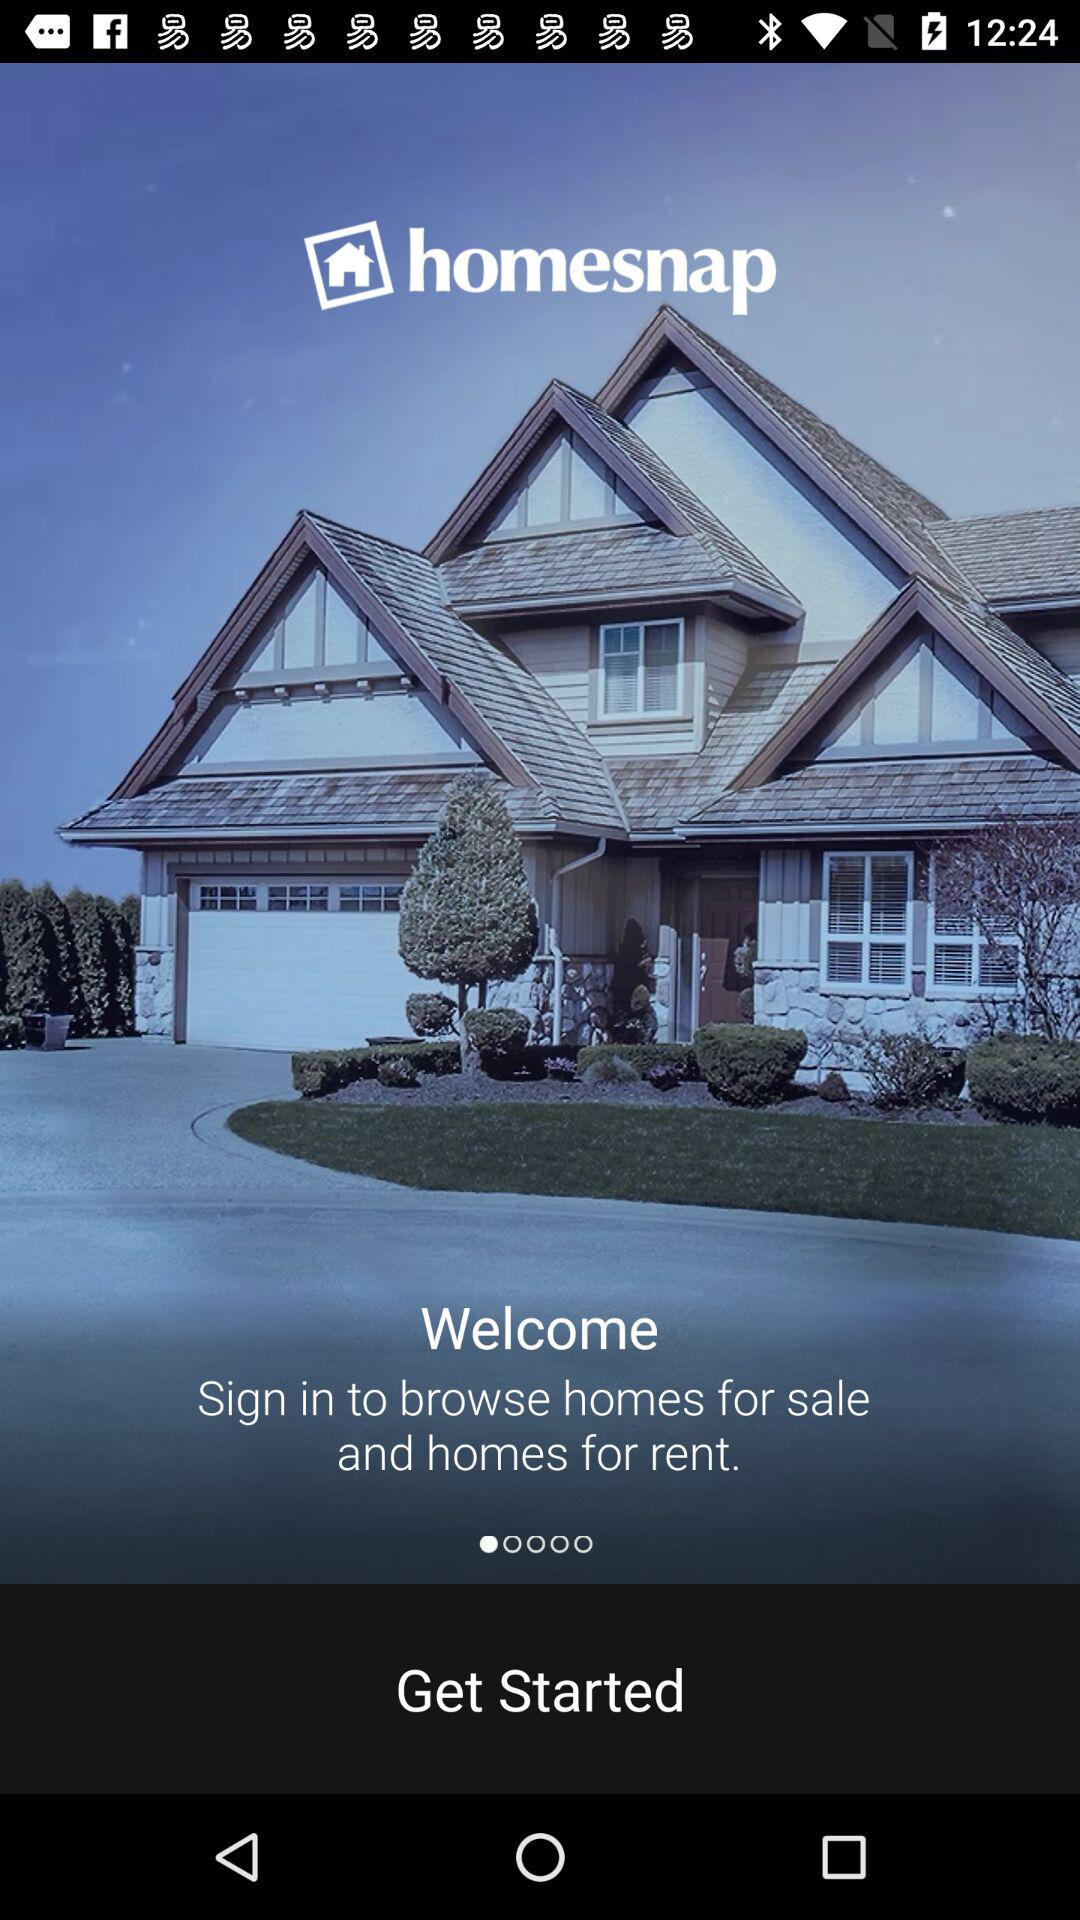What is the application name? The name of the application is "homesnap". 